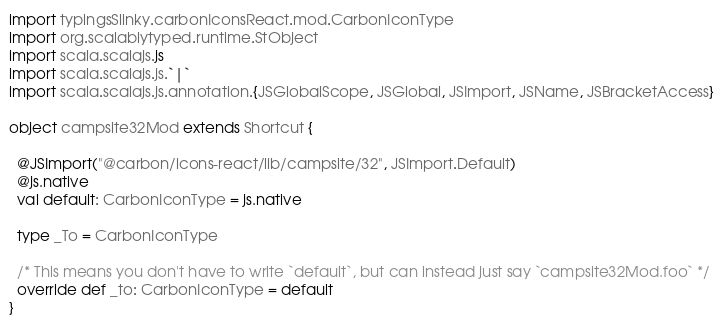<code> <loc_0><loc_0><loc_500><loc_500><_Scala_>import typingsSlinky.carbonIconsReact.mod.CarbonIconType
import org.scalablytyped.runtime.StObject
import scala.scalajs.js
import scala.scalajs.js.`|`
import scala.scalajs.js.annotation.{JSGlobalScope, JSGlobal, JSImport, JSName, JSBracketAccess}

object campsite32Mod extends Shortcut {
  
  @JSImport("@carbon/icons-react/lib/campsite/32", JSImport.Default)
  @js.native
  val default: CarbonIconType = js.native
  
  type _To = CarbonIconType
  
  /* This means you don't have to write `default`, but can instead just say `campsite32Mod.foo` */
  override def _to: CarbonIconType = default
}
</code> 